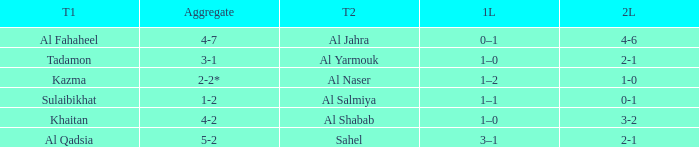What is the name of Team 2 with a 2nd leg of 4-6? Al Jahra. 